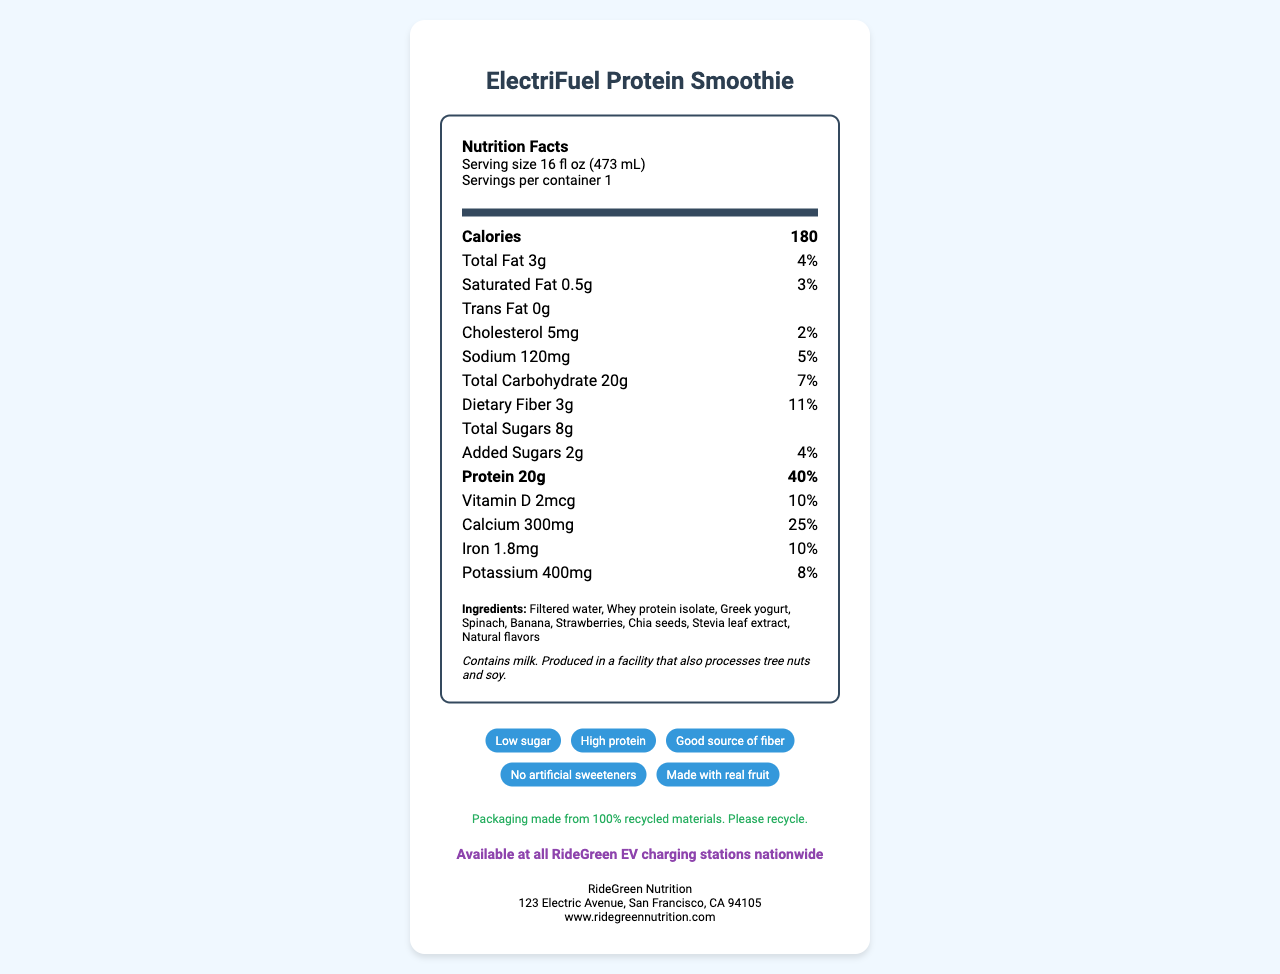what is the serving size? The serving size is indicated in the serving info section at the top of the Nutrition Facts label.
Answer: 16 fl oz (473 mL) how many calories are in one serving? The calorie count is displayed prominently in the bold "Calories" section.
Answer: 180 what is the amount of protein in the smoothie? The protein content is listed under the bold "Protein" section.
Answer: 20g what is the daily value percentage of calcium? The daily value percentage for calcium is noted next to its amount (300mg).
Answer: 25% what kind of sweetener is used in this smoothie? The ingredients list includes Stevia leaf extract as one of the components.
Answer: Stevia leaf extract which company produces this smoothie? A. RideEasy Nutrition B. RideGreen Nutrition C. GreenRide Nutrition The company information section at the bottom states the name "RideGreen Nutrition."
Answer: B. RideGreen Nutrition what ingredients are used in this smoothie? A. Milk, Protein Powder, Chia Seeds, Spinach B. Filtered Water, Whey Protein Isolate, Greek Yogurt, Spinach C. Water, Protein Isolate, Yogurt, Apple The ingredients list includes Filtered water, Whey protein isolate, Greek yogurt, and Spinach among others.
Answer: B. Filtered Water, Whey Protein Isolate, Greek Yogurt, Spinach does this smoothie contain any allergens? The allergen information states that it contains milk and is produced in a facility that also processes tree nuts and soy.
Answer: Yes summarize the main idea of the document. The document provides comprehensive information about the smoothie, including its nutritional breakdown per serving, ingredients used, allergen warnings, and additional claims such as being low in sugar, high in protein, and made with real fruit. It also mentions the company's details and sustainability efforts.
Answer: The document is a Nutrition Facts label for the "ElectriFuel Protein Smoothie," highlighting its nutritional content, ingredients, allergens, company information, sustainability, and availability at RideGreen EV charging stations. what are the claims associated with this product? The claims are listed in the "claims" section of the label.
Answer: Low sugar, High protein, Good source of fiber, No artificial sweeteners, Made with real fruit what is the amount of vitamin d in the smoothie? The nutrition section lists the amount of vitamin D as 2mcg.
Answer: 2mcg what is the amount of added sugars in the smoothie? The amount of added sugars is listed as 2g in the nutrition section.
Answer: 2g where is the company "RideGreen Nutrition" located? The company information section includes the address.
Answer: 123 Electric Avenue, San Francisco, CA 94105 does the smoothie contain any trans fat? The nutrition facts list Trans Fat as 0g.
Answer: No what mineral provides 8% of the daily value in this smoothie? The nutrition section lists Potassium with an 8% daily value.
Answer: Potassium is the packaging of this product recyclable? The sustainability statement indicates that the packaging is made from 100% recycled materials and encourages recycling.
Answer: Yes is this product available at all EV charging stations? The EV charging info states that it is available at all RideGreen EV charging stations nationwide.
Answer: Yes how many grams of total carbohydrates does this smoothie contain? The total amount of carbohydrates is listed as 20g.
Answer: 20g what is the daily value percentage for sodium? The daily value percentage for sodium is noted next to its amount (120mg).
Answer: 5% which ingredient is not listed in the document? A. Stevia leaf extract B. Greek yogurt C. Almond milk The list of ingredients does not include almond milk.
Answer: C. Almond milk is this smoothie suitable for vegan diets? The document lists dairy ingredients such as whey protein isolate and Greek yogurt, but does not mention if there are any non-vegan substitutes or variations available.
Answer: Cannot be determined 